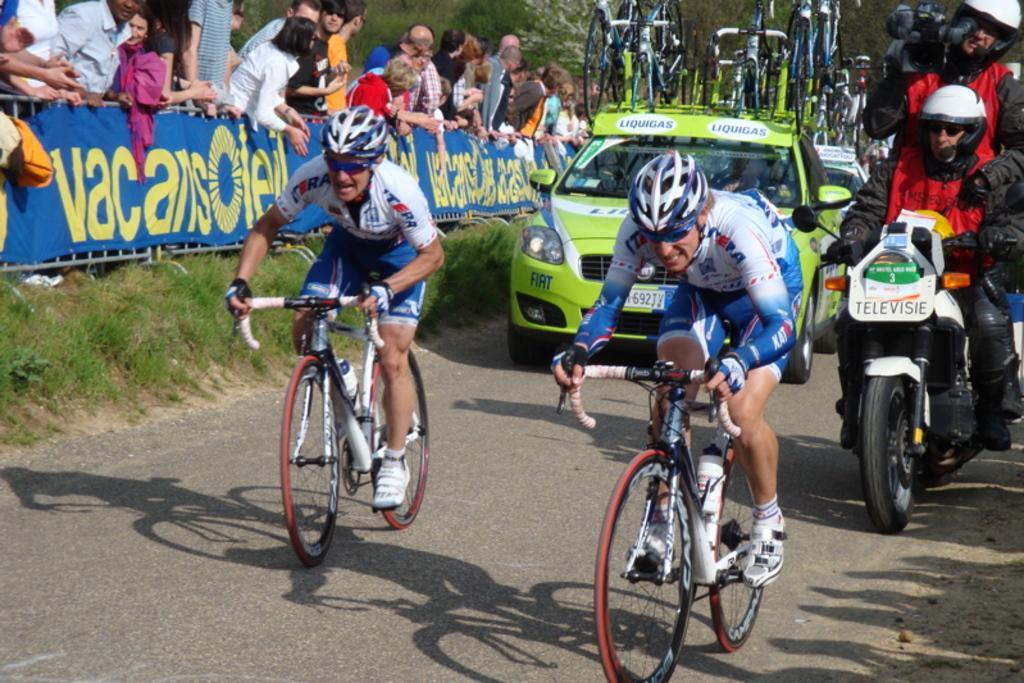Can you describe this image briefly? This picture is clicked outside. On the right we can see the two persons riding bicycles and we can see a person holding a camera and a person riding a bike and we can see the cars running on the road. In the background we can see the group of bicycles, group of persons, grass, banners on which we can see the text and we can see the trees and some other objects. 